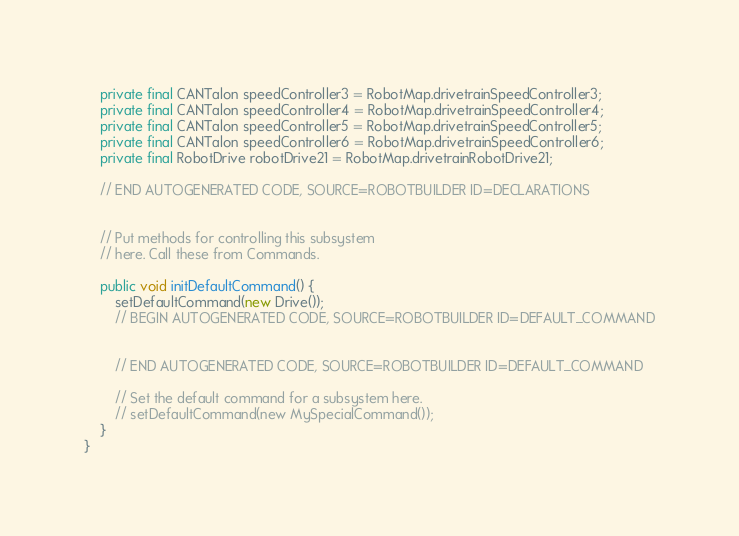Convert code to text. <code><loc_0><loc_0><loc_500><loc_500><_Java_>    private final CANTalon speedController3 = RobotMap.drivetrainSpeedController3;
    private final CANTalon speedController4 = RobotMap.drivetrainSpeedController4;
    private final CANTalon speedController5 = RobotMap.drivetrainSpeedController5;
    private final CANTalon speedController6 = RobotMap.drivetrainSpeedController6;
    private final RobotDrive robotDrive21 = RobotMap.drivetrainRobotDrive21;

    // END AUTOGENERATED CODE, SOURCE=ROBOTBUILDER ID=DECLARATIONS


    // Put methods for controlling this subsystem
    // here. Call these from Commands.

    public void initDefaultCommand() {
    	setDefaultCommand(new Drive());
        // BEGIN AUTOGENERATED CODE, SOURCE=ROBOTBUILDER ID=DEFAULT_COMMAND


        // END AUTOGENERATED CODE, SOURCE=ROBOTBUILDER ID=DEFAULT_COMMAND

        // Set the default command for a subsystem here.
        // setDefaultCommand(new MySpecialCommand());
    }
}

</code> 